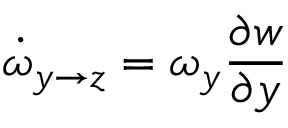Convert formula to latex. <formula><loc_0><loc_0><loc_500><loc_500>\dot { \omega } _ { y \rightarrow z } = \omega _ { y } \frac { \partial w } { \partial y }</formula> 